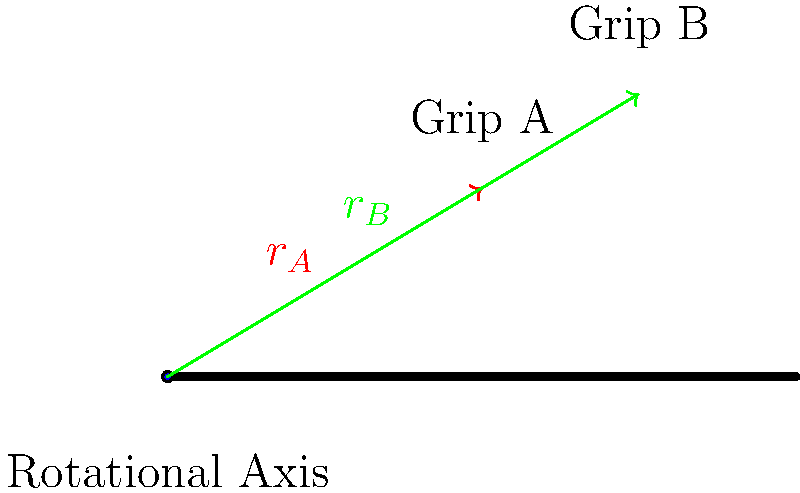A baseball player is experimenting with two different grip positions on their bat. Grip A is located 50 cm from the rotational axis, creating a moment arm $r_A$, while Grip B is 75 cm from the axis, creating a moment arm $r_B$. If the player applies the same force $F$ perpendicular to the bat at both grip positions, how much greater is the torque generated by Grip B compared to Grip A? To solve this problem, we'll follow these steps:

1) Recall the formula for torque: $\tau = r \times F$, where $r$ is the moment arm and $F$ is the applied force.

2) For Grip A: $\tau_A = r_A \times F = 50 \text{ cm} \times F$

3) For Grip B: $\tau_B = r_B \times F = 75 \text{ cm} \times F$

4) To find how much greater the torque is for Grip B, we'll divide $\tau_B$ by $\tau_A$:

   $$\frac{\tau_B}{\tau_A} = \frac{75 \text{ cm} \times F}{50 \text{ cm} \times F}$$

5) The $F$ cancels out in the numerator and denominator:

   $$\frac{\tau_B}{\tau_A} = \frac{75 \text{ cm}}{50 \text{ cm}} = 1.5$$

6) This means that the torque generated by Grip B is 1.5 times greater than the torque generated by Grip A.

7) To express this as a percentage increase:
   
   Percentage increase = $(1.5 - 1) \times 100\% = 0.5 \times 100\% = 50\%$

Therefore, the torque generated by Grip B is 50% greater than the torque generated by Grip A.
Answer: 50% greater 